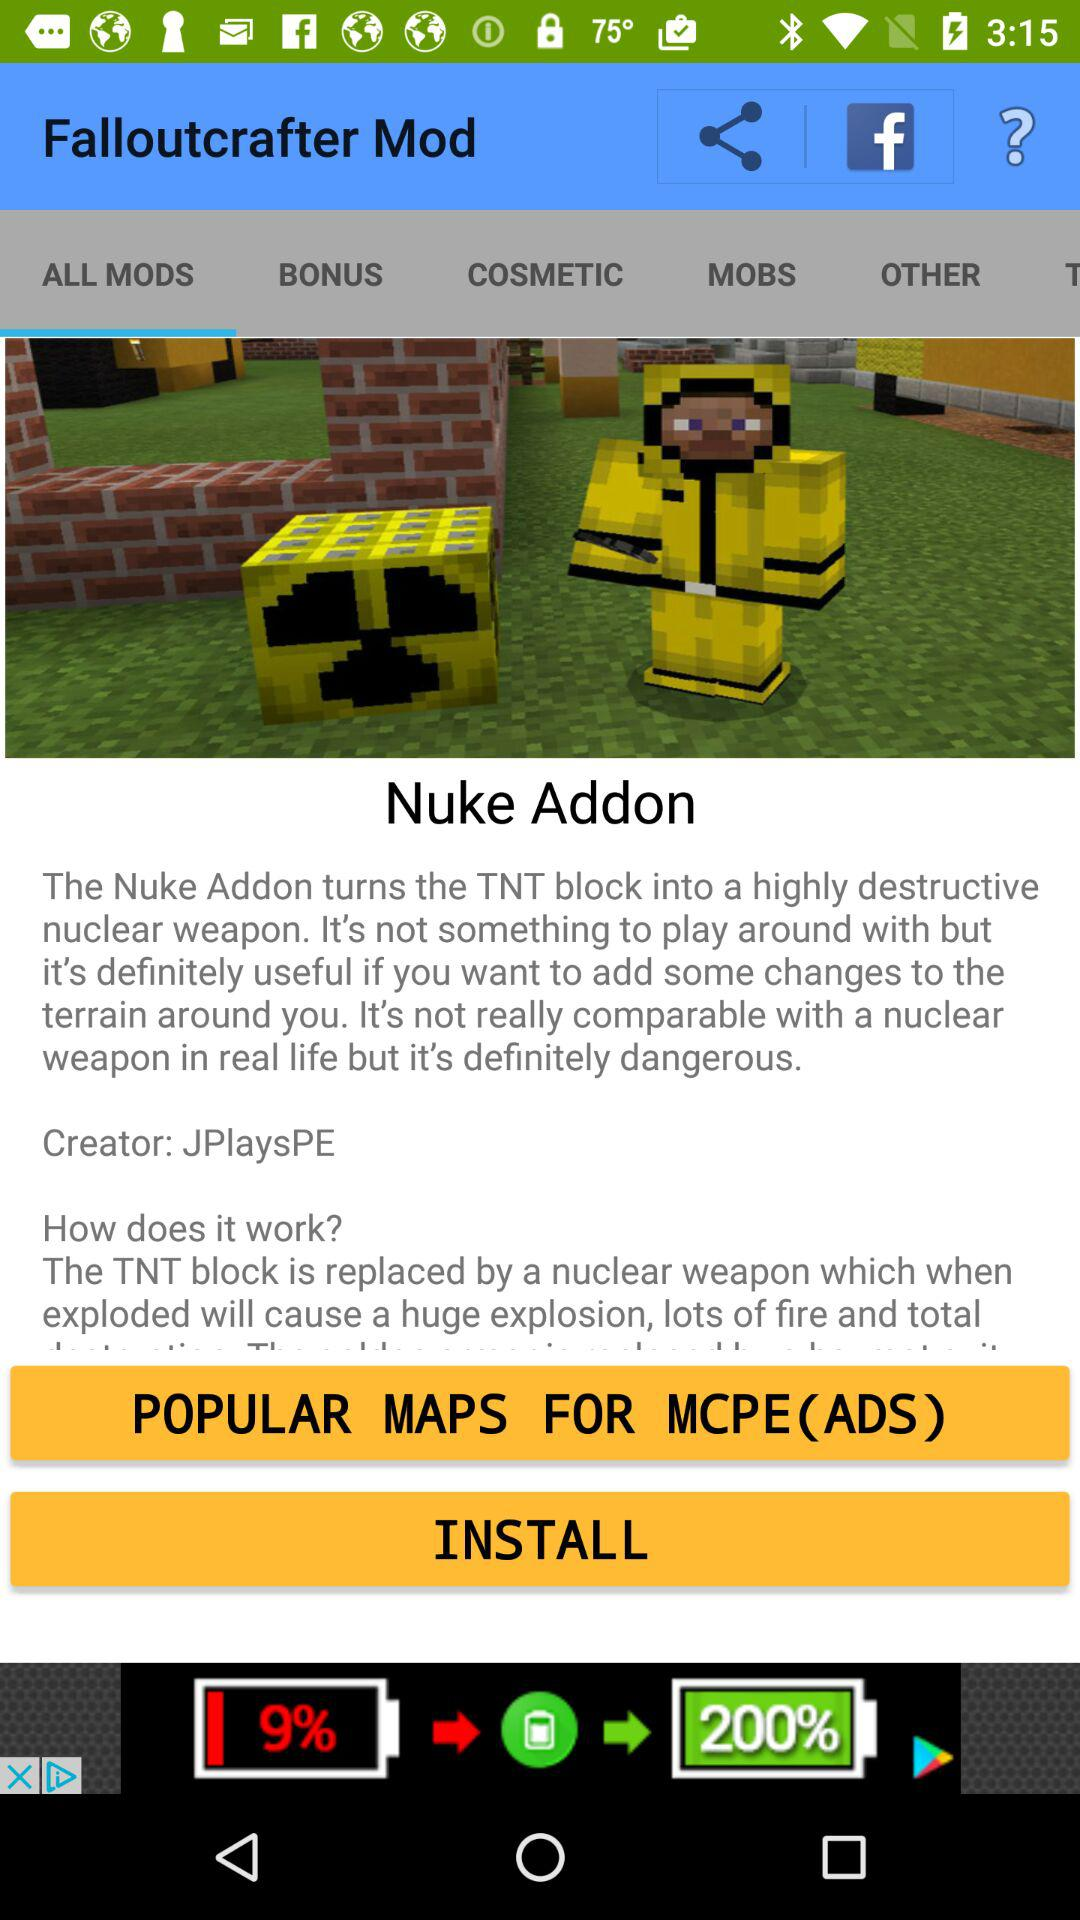Who is the creator of the "Nuke Addon"? The creator is "JPlaysPE". 